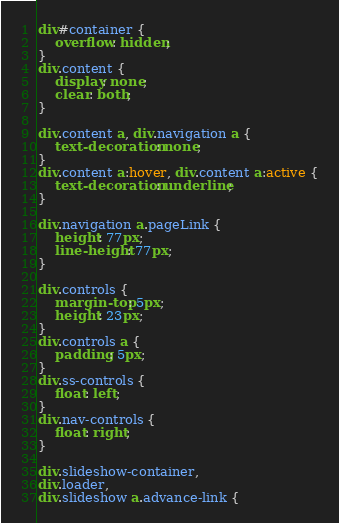Convert code to text. <code><loc_0><loc_0><loc_500><loc_500><_CSS_>div#container {
	overflow: hidden;
}
div.content {
	display: none;
	clear: both;
}

div.content a, div.navigation a {
	text-decoration: none;
}
div.content a:hover, div.content a:active {
	text-decoration: underline;
}

div.navigation a.pageLink {
	height: 77px;
	line-height: 77px;
}

div.controls {
	margin-top: 5px;
	height: 23px;
}
div.controls a {
	padding: 5px;
}
div.ss-controls {
	float: left;
}
div.nav-controls {
	float: right;
}

div.slideshow-container,
div.loader,
div.slideshow a.advance-link {</code> 